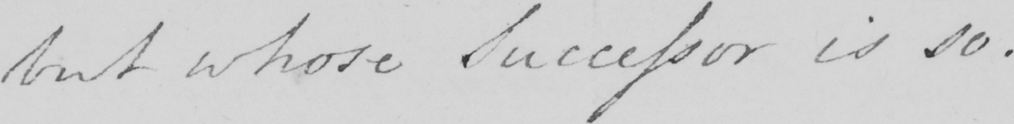What is written in this line of handwriting? but whose Successor is so . 